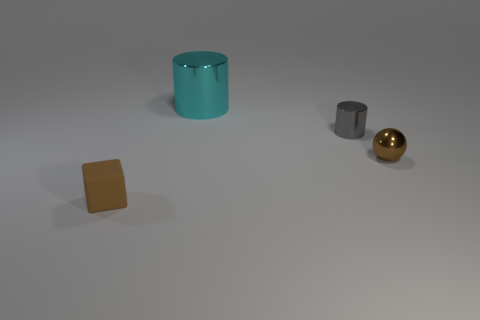Is there anything else that has the same size as the matte object?
Keep it short and to the point. Yes. Does the big metal thing have the same color as the small cylinder?
Ensure brevity in your answer.  No. What color is the small metal object that is behind the small brown thing right of the cyan cylinder?
Make the answer very short. Gray. How many small objects are either rubber cylinders or cyan cylinders?
Provide a succinct answer. 0. The object that is both on the left side of the small shiny cylinder and behind the brown metal ball is what color?
Offer a very short reply. Cyan. Are the brown sphere and the tiny gray cylinder made of the same material?
Offer a very short reply. Yes. The big cyan metal thing is what shape?
Provide a short and direct response. Cylinder. There is a tiny brown object in front of the small brown object behind the brown rubber thing; what number of rubber things are right of it?
Offer a very short reply. 0. There is another metal object that is the same shape as the large shiny thing; what is its color?
Make the answer very short. Gray. The tiny brown object left of the small thing behind the sphere in front of the large object is what shape?
Your answer should be very brief. Cube. 